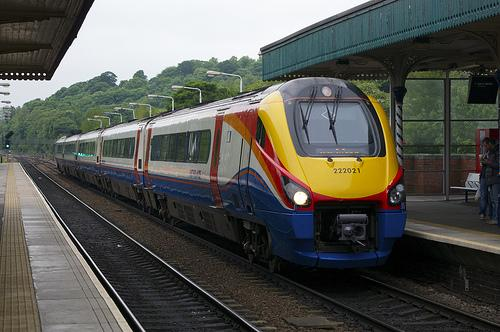Tell me something interesting happening in the scene. A man is standing on the train platform, texting on his phone while waiting for the train. How many people are standing near the tracks? There are two people standing near the tracks. Create a haiku about the scene depicted in the image (it doesn't strictly have to follow the 5-7-5 syllable structure, but should still be concise). Tracks speak of journeys. Identify the colors present on the train's exterior. The train has yellow, blue, red, and white colors on its exterior. Provide a poetic description of the weather in the image. The sky paints a cloudy, clear yet grayish canvas, with a moody atmosphere. Estimate the number aboard the train based on the number of visible windows. There are approximately 8 windows visible in a row, so there might be around 8 passengers aboard, assuming one passenger per window. In a playful manner, describe an object on the train's front. Peeking from the train's front, a cheery green light gives the go-ahead signal to the conductor, ready to embark on its next journey. What mode of transportation is mainly depicted in this image? A high-speed public train at a train station. What safety precaution is taken for passengers on the platform? There is a thick yellow line on the ground, which passengers should stay behind to maintain distance from the train. Briefly describe the scene outside the train in the image. There are people waiting at the train platform, tall trees in the background, two parallel sets of train tracks, and a row of overhead lights. Is there a cat sitting on the platform near the train? No, it's not mentioned in the image. Compare the image of the train with the statement: "A blue and green train is leaving the station." Contradiction List some of the objects on the train station platform. A bench, striped pole, row of overhead lights, and thick yellow line Describe the train on the tracks. A red, blue, and yellow high-speed public train with the number 222021 on the front What type of light is shining in the distance at the train station? Green go ahead train light Choose the best description of the train's windshield from the options: a) without windshield wipers, b) with windshield wipers, c) broken. b) with windshield wipers Identify the emotion of the person standing near the train. Cannot determine, no clear facial expression Are there three people standing near the train wearing orange hats? Although there are people standing near the train, it doesn't mention the number or that they're wearing orange hats. Identify if there is a potential safety precaution for passengers near the train tracks. Yes, the thick yellow line on the ground What action is the man standing and texting on a train platform performing? Texting Decode the text on the black sign giving passengers directions. Cannot read, the text is too small What is the train's number posted on the front? 222021 Identify the relationship between the image of the train and the statement: "A yellow and blue train is parked at the station." Entailment Describe the scenery around the train station. Cloudy sky, tall trees with green tops, streetlights in a row, and two parallel sets of train tracks What type of train is depicted in the image? A high-speed public train What is the purpose of the thick yellow line on the ground? To maintain a safe distance for passengers from the train tracks What color is the train on the tracks? Red, blue, and yellow Is the train on the right side of the tracks green in color? The image contains a train, but it is not mentioned as green. It has red, blue, and yellow colors. Is there an empty train track in the image? Yes or No. Yes Explain the role of the glass encasing at the train stop. To protect passengers from wind, rain, or debris. What activity are the two people waiting for a train engaged in? Waiting or standing What purpose do the windshield wipers on the train serve? To clear the windshield of rain or debris for better visibility 